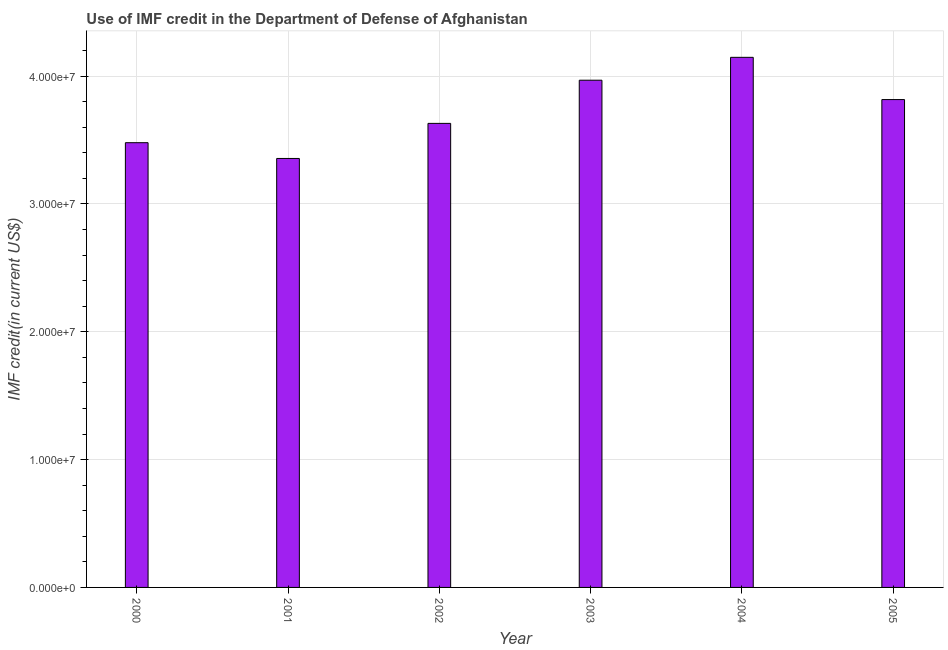Does the graph contain any zero values?
Offer a terse response. No. What is the title of the graph?
Provide a succinct answer. Use of IMF credit in the Department of Defense of Afghanistan. What is the label or title of the Y-axis?
Your answer should be very brief. IMF credit(in current US$). What is the use of imf credit in dod in 2001?
Your answer should be compact. 3.36e+07. Across all years, what is the maximum use of imf credit in dod?
Keep it short and to the point. 4.15e+07. Across all years, what is the minimum use of imf credit in dod?
Provide a short and direct response. 3.36e+07. In which year was the use of imf credit in dod maximum?
Keep it short and to the point. 2004. What is the sum of the use of imf credit in dod?
Make the answer very short. 2.24e+08. What is the difference between the use of imf credit in dod in 2001 and 2005?
Make the answer very short. -4.61e+06. What is the average use of imf credit in dod per year?
Your response must be concise. 3.73e+07. What is the median use of imf credit in dod?
Provide a short and direct response. 3.72e+07. In how many years, is the use of imf credit in dod greater than 38000000 US$?
Your response must be concise. 3. What is the ratio of the use of imf credit in dod in 2000 to that in 2004?
Keep it short and to the point. 0.84. Is the difference between the use of imf credit in dod in 2004 and 2005 greater than the difference between any two years?
Offer a terse response. No. What is the difference between the highest and the second highest use of imf credit in dod?
Provide a short and direct response. 1.79e+06. What is the difference between the highest and the lowest use of imf credit in dod?
Provide a succinct answer. 7.91e+06. In how many years, is the use of imf credit in dod greater than the average use of imf credit in dod taken over all years?
Your answer should be compact. 3. Are all the bars in the graph horizontal?
Your response must be concise. No. Are the values on the major ticks of Y-axis written in scientific E-notation?
Offer a very short reply. Yes. What is the IMF credit(in current US$) in 2000?
Keep it short and to the point. 3.48e+07. What is the IMF credit(in current US$) of 2001?
Your answer should be very brief. 3.36e+07. What is the IMF credit(in current US$) in 2002?
Give a very brief answer. 3.63e+07. What is the IMF credit(in current US$) in 2003?
Keep it short and to the point. 3.97e+07. What is the IMF credit(in current US$) in 2004?
Provide a short and direct response. 4.15e+07. What is the IMF credit(in current US$) of 2005?
Make the answer very short. 3.82e+07. What is the difference between the IMF credit(in current US$) in 2000 and 2001?
Offer a very short reply. 1.23e+06. What is the difference between the IMF credit(in current US$) in 2000 and 2002?
Your response must be concise. -1.51e+06. What is the difference between the IMF credit(in current US$) in 2000 and 2003?
Offer a terse response. -4.89e+06. What is the difference between the IMF credit(in current US$) in 2000 and 2004?
Your response must be concise. -6.68e+06. What is the difference between the IMF credit(in current US$) in 2000 and 2005?
Make the answer very short. -3.37e+06. What is the difference between the IMF credit(in current US$) in 2001 and 2002?
Provide a succinct answer. -2.74e+06. What is the difference between the IMF credit(in current US$) in 2001 and 2003?
Offer a very short reply. -6.12e+06. What is the difference between the IMF credit(in current US$) in 2001 and 2004?
Your answer should be very brief. -7.91e+06. What is the difference between the IMF credit(in current US$) in 2001 and 2005?
Give a very brief answer. -4.61e+06. What is the difference between the IMF credit(in current US$) in 2002 and 2003?
Provide a succinct answer. -3.38e+06. What is the difference between the IMF credit(in current US$) in 2002 and 2004?
Ensure brevity in your answer.  -5.17e+06. What is the difference between the IMF credit(in current US$) in 2002 and 2005?
Offer a very short reply. -1.86e+06. What is the difference between the IMF credit(in current US$) in 2003 and 2004?
Provide a succinct answer. -1.79e+06. What is the difference between the IMF credit(in current US$) in 2003 and 2005?
Ensure brevity in your answer.  1.51e+06. What is the difference between the IMF credit(in current US$) in 2004 and 2005?
Your answer should be very brief. 3.30e+06. What is the ratio of the IMF credit(in current US$) in 2000 to that in 2002?
Offer a very short reply. 0.96. What is the ratio of the IMF credit(in current US$) in 2000 to that in 2003?
Offer a terse response. 0.88. What is the ratio of the IMF credit(in current US$) in 2000 to that in 2004?
Your response must be concise. 0.84. What is the ratio of the IMF credit(in current US$) in 2000 to that in 2005?
Your answer should be very brief. 0.91. What is the ratio of the IMF credit(in current US$) in 2001 to that in 2002?
Provide a succinct answer. 0.92. What is the ratio of the IMF credit(in current US$) in 2001 to that in 2003?
Keep it short and to the point. 0.85. What is the ratio of the IMF credit(in current US$) in 2001 to that in 2004?
Make the answer very short. 0.81. What is the ratio of the IMF credit(in current US$) in 2001 to that in 2005?
Ensure brevity in your answer.  0.88. What is the ratio of the IMF credit(in current US$) in 2002 to that in 2003?
Your answer should be very brief. 0.92. What is the ratio of the IMF credit(in current US$) in 2002 to that in 2004?
Give a very brief answer. 0.88. What is the ratio of the IMF credit(in current US$) in 2002 to that in 2005?
Offer a very short reply. 0.95. What is the ratio of the IMF credit(in current US$) in 2003 to that in 2004?
Your answer should be very brief. 0.96. What is the ratio of the IMF credit(in current US$) in 2004 to that in 2005?
Provide a succinct answer. 1.09. 